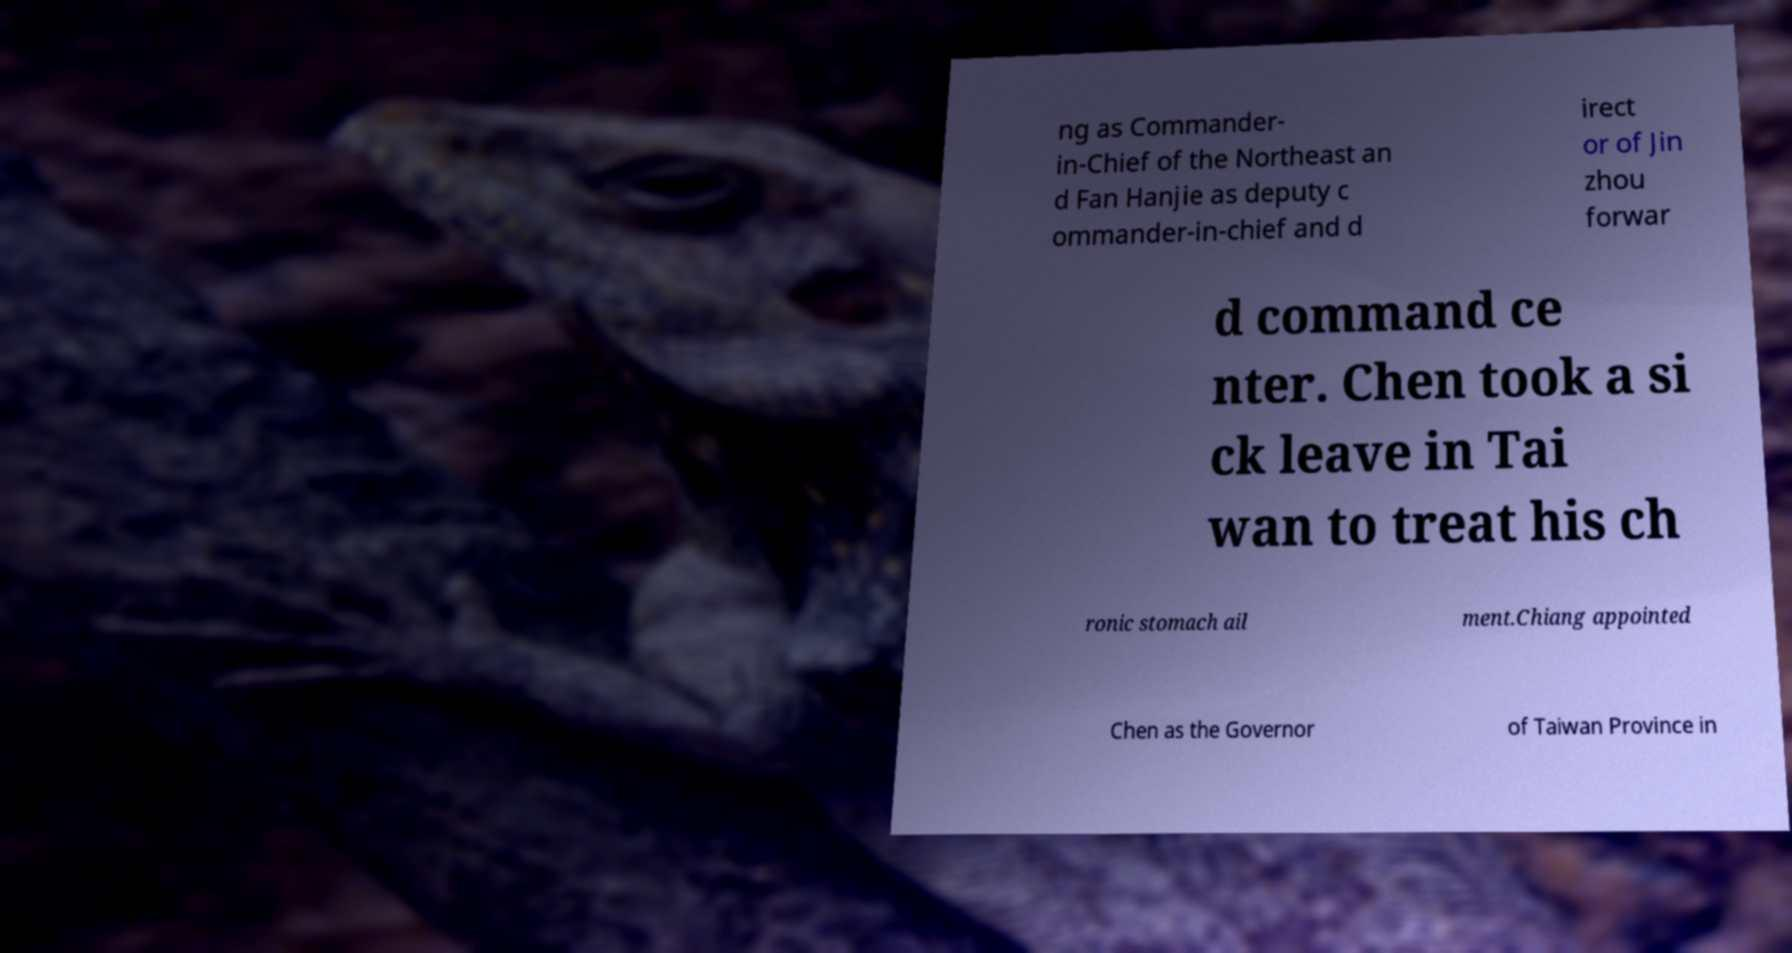Please identify and transcribe the text found in this image. ng as Commander- in-Chief of the Northeast an d Fan Hanjie as deputy c ommander-in-chief and d irect or of Jin zhou forwar d command ce nter. Chen took a si ck leave in Tai wan to treat his ch ronic stomach ail ment.Chiang appointed Chen as the Governor of Taiwan Province in 